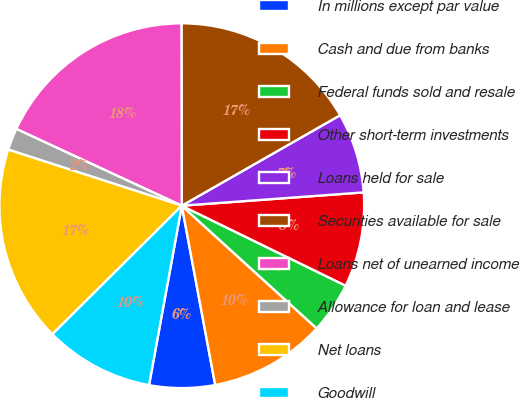Convert chart. <chart><loc_0><loc_0><loc_500><loc_500><pie_chart><fcel>In millions except par value<fcel>Cash and due from banks<fcel>Federal funds sold and resale<fcel>Other short-term investments<fcel>Loans held for sale<fcel>Securities available for sale<fcel>Loans net of unearned income<fcel>Allowance for loan and lease<fcel>Net loans<fcel>Goodwill<nl><fcel>5.81%<fcel>10.32%<fcel>4.52%<fcel>8.39%<fcel>7.1%<fcel>16.77%<fcel>18.06%<fcel>1.94%<fcel>17.42%<fcel>9.68%<nl></chart> 